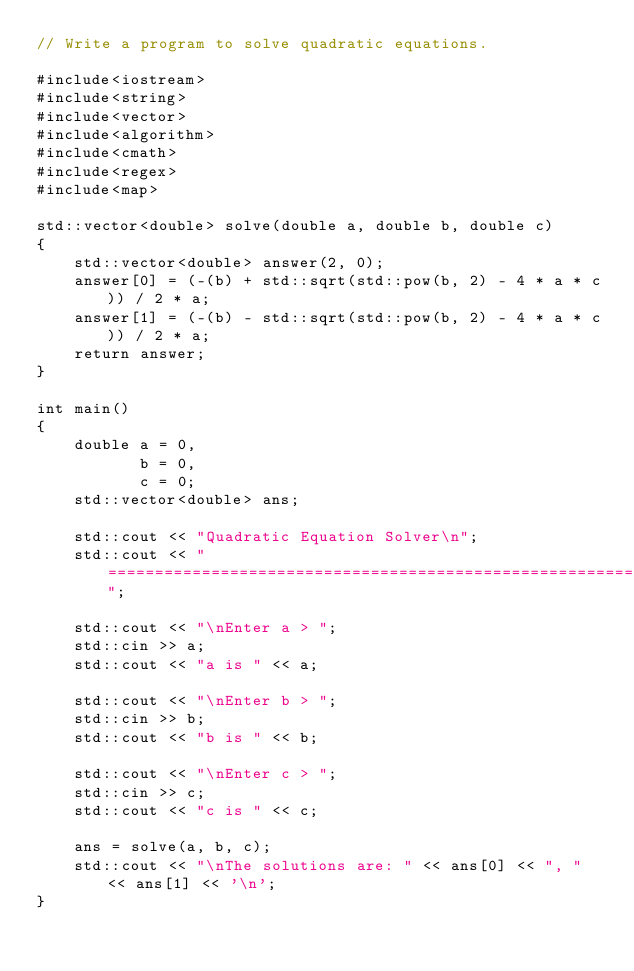<code> <loc_0><loc_0><loc_500><loc_500><_C++_>// Write a program to solve quadratic equations.

#include<iostream>
#include<string>
#include<vector>
#include<algorithm>
#include<cmath>
#include<regex>
#include<map>

std::vector<double> solve(double a, double b, double c)
{
    std::vector<double> answer(2, 0);
    answer[0] = (-(b) + std::sqrt(std::pow(b, 2) - 4 * a * c)) / 2 * a;
    answer[1] = (-(b) - std::sqrt(std::pow(b, 2) - 4 * a * c)) / 2 * a;
    return answer;
}

int main()
{
    double a = 0,
           b = 0,
           c = 0;
    std::vector<double> ans;

    std::cout << "Quadratic Equation Solver\n";
    std::cout << "===========================================================";

    std::cout << "\nEnter a > ";
    std::cin >> a;
    std::cout << "a is " << a;

    std::cout << "\nEnter b > ";
    std::cin >> b;
    std::cout << "b is " << b;

    std::cout << "\nEnter c > ";
    std::cin >> c;
    std::cout << "c is " << c;

    ans = solve(a, b, c);
    std::cout << "\nThe solutions are: " << ans[0] << ", " << ans[1] << '\n';
}
</code> 